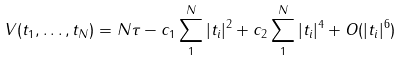<formula> <loc_0><loc_0><loc_500><loc_500>V ( t _ { 1 } , \dots , t _ { N } ) = N \tau - c _ { 1 } \sum _ { 1 } ^ { N } | t _ { i } | ^ { 2 } + c _ { 2 } \sum _ { 1 } ^ { N } | t _ { i } | ^ { 4 } + O ( | t _ { i } | ^ { 6 } )</formula> 